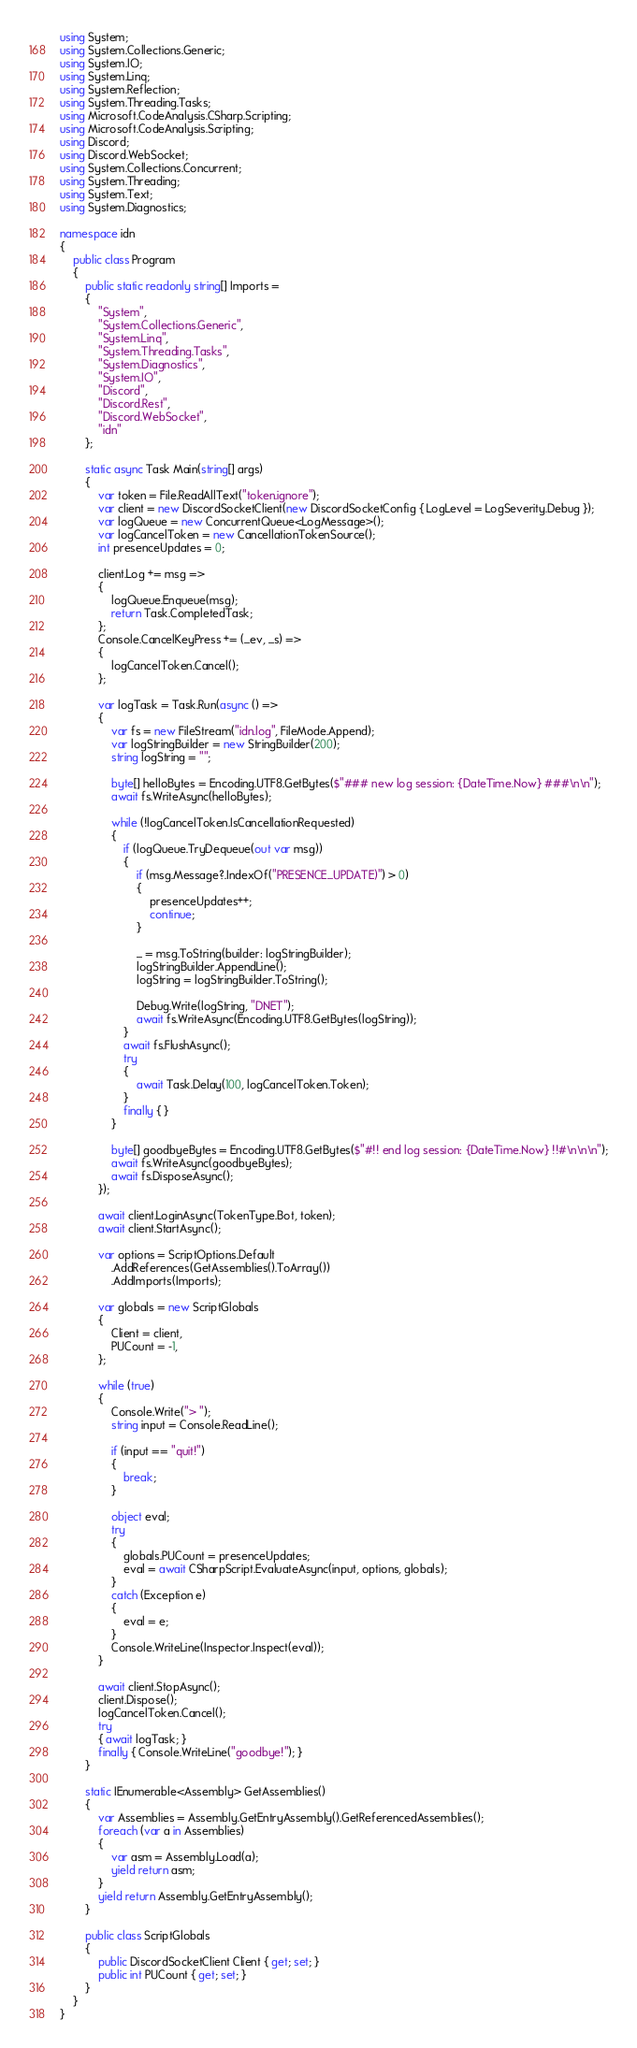<code> <loc_0><loc_0><loc_500><loc_500><_C#_>using System;
using System.Collections.Generic;
using System.IO;
using System.Linq;
using System.Reflection;
using System.Threading.Tasks;
using Microsoft.CodeAnalysis.CSharp.Scripting;
using Microsoft.CodeAnalysis.Scripting;
using Discord;
using Discord.WebSocket;
using System.Collections.Concurrent;
using System.Threading;
using System.Text;
using System.Diagnostics;

namespace idn
{
    public class Program
    {
        public static readonly string[] Imports =
        {
            "System",
            "System.Collections.Generic",
            "System.Linq",
            "System.Threading.Tasks",
            "System.Diagnostics",
            "System.IO",
            "Discord",
            "Discord.Rest",
            "Discord.WebSocket",
            "idn"
        };

        static async Task Main(string[] args)
        {
            var token = File.ReadAllText("token.ignore");
            var client = new DiscordSocketClient(new DiscordSocketConfig { LogLevel = LogSeverity.Debug });
            var logQueue = new ConcurrentQueue<LogMessage>();
            var logCancelToken = new CancellationTokenSource();
            int presenceUpdates = 0;

            client.Log += msg =>
            {
                logQueue.Enqueue(msg);
                return Task.CompletedTask;
            };
            Console.CancelKeyPress += (_ev, _s) =>
            {
                logCancelToken.Cancel();
            };

            var logTask = Task.Run(async () =>
            {
                var fs = new FileStream("idn.log", FileMode.Append);
                var logStringBuilder = new StringBuilder(200);
                string logString = "";

                byte[] helloBytes = Encoding.UTF8.GetBytes($"### new log session: {DateTime.Now} ###\n\n");
                await fs.WriteAsync(helloBytes);

                while (!logCancelToken.IsCancellationRequested)
                {
                    if (logQueue.TryDequeue(out var msg))
                    {
                        if (msg.Message?.IndexOf("PRESENCE_UPDATE)") > 0)
                        {
                            presenceUpdates++;
                            continue;
                        }

                        _ = msg.ToString(builder: logStringBuilder);
                        logStringBuilder.AppendLine();
                        logString = logStringBuilder.ToString();

                        Debug.Write(logString, "DNET");
                        await fs.WriteAsync(Encoding.UTF8.GetBytes(logString));
                    }
                    await fs.FlushAsync();
                    try
                    {
                        await Task.Delay(100, logCancelToken.Token);
                    }
                    finally { }
                }

                byte[] goodbyeBytes = Encoding.UTF8.GetBytes($"#!! end log session: {DateTime.Now} !!#\n\n\n");
                await fs.WriteAsync(goodbyeBytes);
                await fs.DisposeAsync();
            });

            await client.LoginAsync(TokenType.Bot, token);
            await client.StartAsync();

            var options = ScriptOptions.Default
                .AddReferences(GetAssemblies().ToArray())
                .AddImports(Imports);

            var globals = new ScriptGlobals
            {
                Client = client,
                PUCount = -1,
            };

            while (true)
            {
                Console.Write("> ");
                string input = Console.ReadLine();

                if (input == "quit!")
                {
                    break;
                }

                object eval;
                try
                {
                    globals.PUCount = presenceUpdates;
                    eval = await CSharpScript.EvaluateAsync(input, options, globals);
                }
                catch (Exception e)
                {
                    eval = e;
                }
                Console.WriteLine(Inspector.Inspect(eval));
            }

            await client.StopAsync();
            client.Dispose();
            logCancelToken.Cancel();
            try
            { await logTask; }
            finally { Console.WriteLine("goodbye!"); }
        }

        static IEnumerable<Assembly> GetAssemblies()
        {
            var Assemblies = Assembly.GetEntryAssembly().GetReferencedAssemblies();
            foreach (var a in Assemblies)
            {
                var asm = Assembly.Load(a);
                yield return asm;
            }
            yield return Assembly.GetEntryAssembly();
        }

        public class ScriptGlobals
        {
            public DiscordSocketClient Client { get; set; }
            public int PUCount { get; set; }
        }
    }
}
</code> 